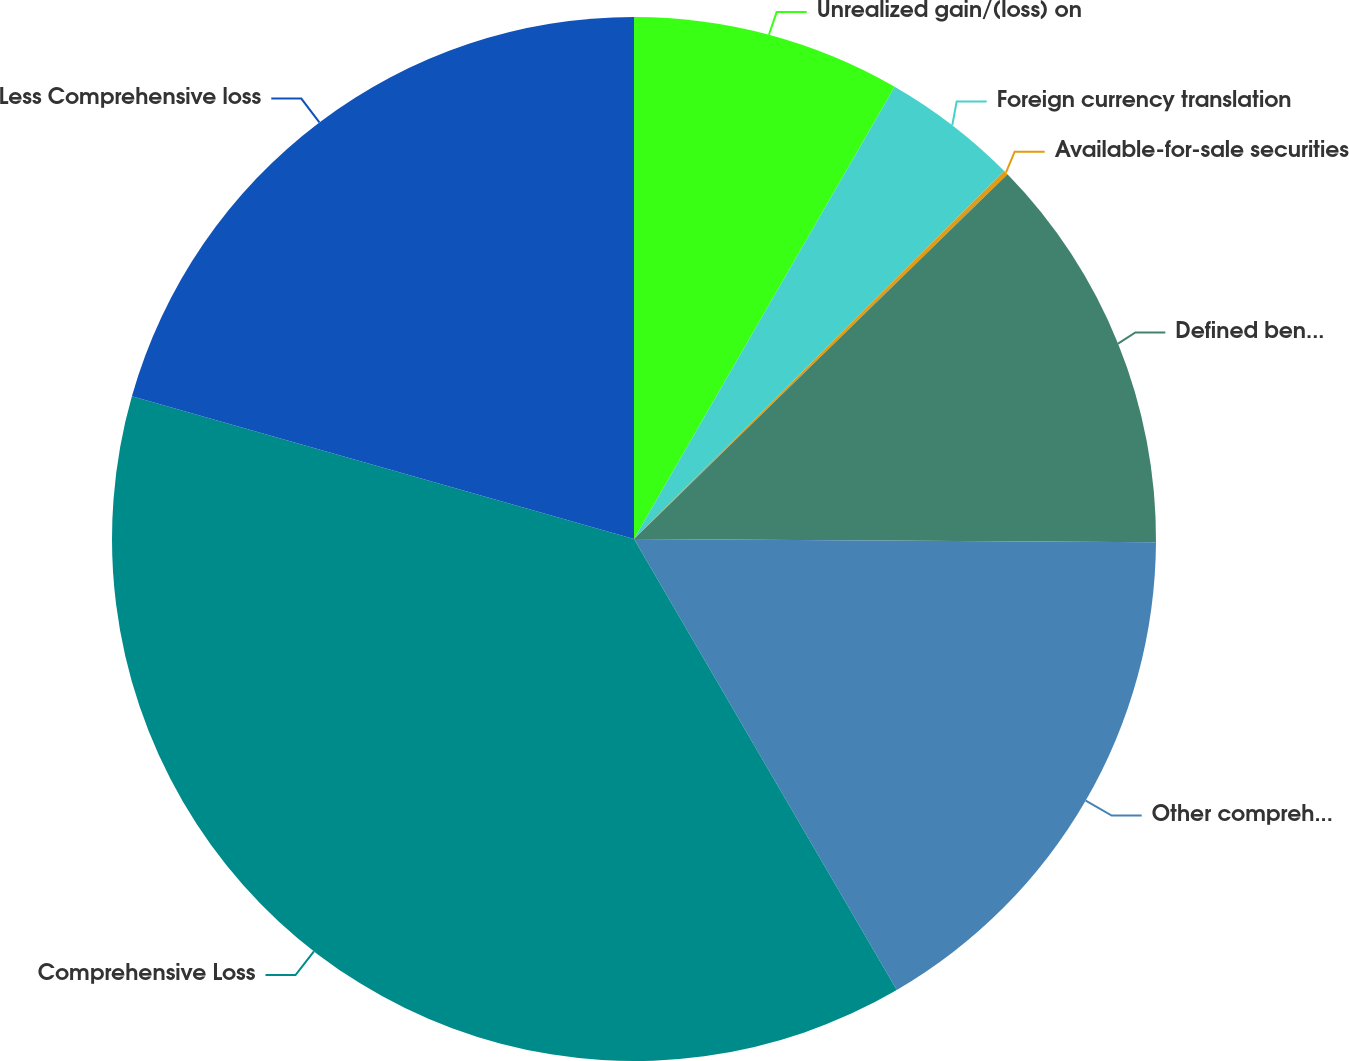<chart> <loc_0><loc_0><loc_500><loc_500><pie_chart><fcel>Unrealized gain/(loss) on<fcel>Foreign currency translation<fcel>Available-for-sale securities<fcel>Defined benefit plan net of<fcel>Other comprehensive income<fcel>Comprehensive Loss<fcel>Less Comprehensive loss<nl><fcel>8.32%<fcel>4.23%<fcel>0.14%<fcel>12.41%<fcel>16.5%<fcel>37.8%<fcel>20.59%<nl></chart> 